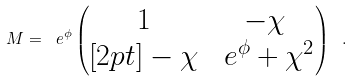Convert formula to latex. <formula><loc_0><loc_0><loc_500><loc_500>M = \ e ^ { \phi } \begin{pmatrix} 1 & - \chi \\ [ 2 p t ] - \chi & \ e ^ { \phi } + \chi ^ { 2 } \end{pmatrix} \ .</formula> 